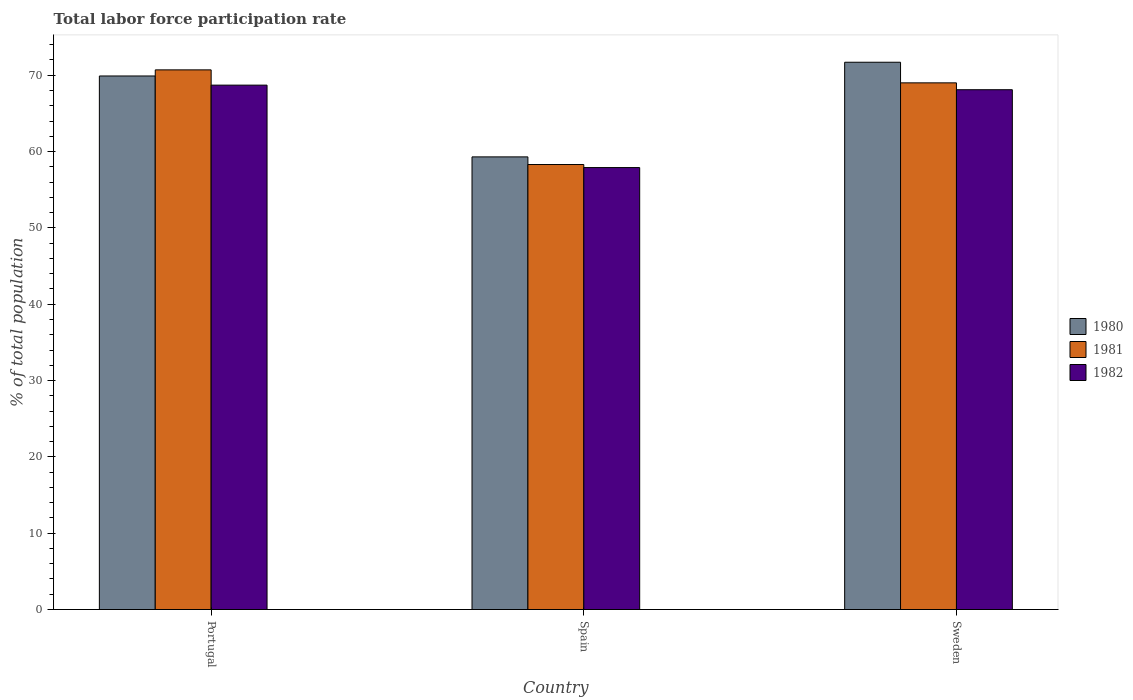Are the number of bars per tick equal to the number of legend labels?
Make the answer very short. Yes. Are the number of bars on each tick of the X-axis equal?
Provide a short and direct response. Yes. How many bars are there on the 1st tick from the right?
Offer a very short reply. 3. What is the total labor force participation rate in 1980 in Portugal?
Provide a short and direct response. 69.9. Across all countries, what is the maximum total labor force participation rate in 1982?
Provide a succinct answer. 68.7. Across all countries, what is the minimum total labor force participation rate in 1980?
Provide a succinct answer. 59.3. In which country was the total labor force participation rate in 1982 maximum?
Give a very brief answer. Portugal. In which country was the total labor force participation rate in 1981 minimum?
Make the answer very short. Spain. What is the total total labor force participation rate in 1982 in the graph?
Ensure brevity in your answer.  194.7. What is the difference between the total labor force participation rate in 1980 in Spain and that in Sweden?
Make the answer very short. -12.4. What is the average total labor force participation rate in 1982 per country?
Your response must be concise. 64.9. In how many countries, is the total labor force participation rate in 1982 greater than 64 %?
Your answer should be compact. 2. What is the ratio of the total labor force participation rate in 1982 in Spain to that in Sweden?
Make the answer very short. 0.85. Is the total labor force participation rate in 1980 in Spain less than that in Sweden?
Provide a short and direct response. Yes. What is the difference between the highest and the second highest total labor force participation rate in 1980?
Your answer should be compact. -10.6. What is the difference between the highest and the lowest total labor force participation rate in 1981?
Your response must be concise. 12.4. In how many countries, is the total labor force participation rate in 1980 greater than the average total labor force participation rate in 1980 taken over all countries?
Offer a very short reply. 2. What does the 3rd bar from the left in Sweden represents?
Your answer should be compact. 1982. What does the 2nd bar from the right in Spain represents?
Make the answer very short. 1981. Is it the case that in every country, the sum of the total labor force participation rate in 1981 and total labor force participation rate in 1982 is greater than the total labor force participation rate in 1980?
Provide a short and direct response. Yes. Are all the bars in the graph horizontal?
Provide a succinct answer. No. What is the difference between two consecutive major ticks on the Y-axis?
Make the answer very short. 10. Does the graph contain any zero values?
Ensure brevity in your answer.  No. Does the graph contain grids?
Your answer should be very brief. No. Where does the legend appear in the graph?
Your answer should be compact. Center right. How many legend labels are there?
Your answer should be compact. 3. What is the title of the graph?
Give a very brief answer. Total labor force participation rate. Does "1969" appear as one of the legend labels in the graph?
Ensure brevity in your answer.  No. What is the label or title of the Y-axis?
Provide a short and direct response. % of total population. What is the % of total population of 1980 in Portugal?
Your answer should be very brief. 69.9. What is the % of total population of 1981 in Portugal?
Your answer should be very brief. 70.7. What is the % of total population in 1982 in Portugal?
Give a very brief answer. 68.7. What is the % of total population in 1980 in Spain?
Offer a very short reply. 59.3. What is the % of total population of 1981 in Spain?
Provide a short and direct response. 58.3. What is the % of total population of 1982 in Spain?
Provide a succinct answer. 57.9. What is the % of total population in 1980 in Sweden?
Offer a very short reply. 71.7. What is the % of total population in 1982 in Sweden?
Ensure brevity in your answer.  68.1. Across all countries, what is the maximum % of total population of 1980?
Ensure brevity in your answer.  71.7. Across all countries, what is the maximum % of total population of 1981?
Ensure brevity in your answer.  70.7. Across all countries, what is the maximum % of total population of 1982?
Your response must be concise. 68.7. Across all countries, what is the minimum % of total population of 1980?
Provide a short and direct response. 59.3. Across all countries, what is the minimum % of total population of 1981?
Give a very brief answer. 58.3. Across all countries, what is the minimum % of total population of 1982?
Keep it short and to the point. 57.9. What is the total % of total population of 1980 in the graph?
Ensure brevity in your answer.  200.9. What is the total % of total population in 1981 in the graph?
Keep it short and to the point. 198. What is the total % of total population in 1982 in the graph?
Your answer should be very brief. 194.7. What is the difference between the % of total population in 1980 in Portugal and that in Sweden?
Your answer should be very brief. -1.8. What is the difference between the % of total population of 1981 in Portugal and that in Sweden?
Provide a succinct answer. 1.7. What is the difference between the % of total population of 1980 in Spain and that in Sweden?
Offer a terse response. -12.4. What is the difference between the % of total population of 1981 in Portugal and the % of total population of 1982 in Spain?
Your answer should be compact. 12.8. What is the difference between the % of total population of 1980 in Portugal and the % of total population of 1982 in Sweden?
Your answer should be very brief. 1.8. What is the difference between the % of total population in 1980 in Spain and the % of total population in 1981 in Sweden?
Keep it short and to the point. -9.7. What is the average % of total population in 1980 per country?
Make the answer very short. 66.97. What is the average % of total population of 1982 per country?
Your answer should be very brief. 64.9. What is the difference between the % of total population in 1980 and % of total population in 1981 in Portugal?
Ensure brevity in your answer.  -0.8. What is the difference between the % of total population of 1980 and % of total population of 1982 in Portugal?
Make the answer very short. 1.2. What is the difference between the % of total population in 1981 and % of total population in 1982 in Portugal?
Provide a succinct answer. 2. What is the difference between the % of total population in 1981 and % of total population in 1982 in Spain?
Offer a very short reply. 0.4. What is the difference between the % of total population of 1980 and % of total population of 1982 in Sweden?
Offer a very short reply. 3.6. What is the difference between the % of total population of 1981 and % of total population of 1982 in Sweden?
Offer a very short reply. 0.9. What is the ratio of the % of total population in 1980 in Portugal to that in Spain?
Your response must be concise. 1.18. What is the ratio of the % of total population of 1981 in Portugal to that in Spain?
Offer a very short reply. 1.21. What is the ratio of the % of total population of 1982 in Portugal to that in Spain?
Offer a very short reply. 1.19. What is the ratio of the % of total population of 1980 in Portugal to that in Sweden?
Offer a very short reply. 0.97. What is the ratio of the % of total population of 1981 in Portugal to that in Sweden?
Offer a very short reply. 1.02. What is the ratio of the % of total population of 1982 in Portugal to that in Sweden?
Provide a succinct answer. 1.01. What is the ratio of the % of total population of 1980 in Spain to that in Sweden?
Keep it short and to the point. 0.83. What is the ratio of the % of total population in 1981 in Spain to that in Sweden?
Make the answer very short. 0.84. What is the ratio of the % of total population in 1982 in Spain to that in Sweden?
Offer a terse response. 0.85. What is the difference between the highest and the second highest % of total population of 1980?
Offer a very short reply. 1.8. What is the difference between the highest and the second highest % of total population of 1981?
Your response must be concise. 1.7. What is the difference between the highest and the second highest % of total population of 1982?
Keep it short and to the point. 0.6. What is the difference between the highest and the lowest % of total population in 1982?
Give a very brief answer. 10.8. 